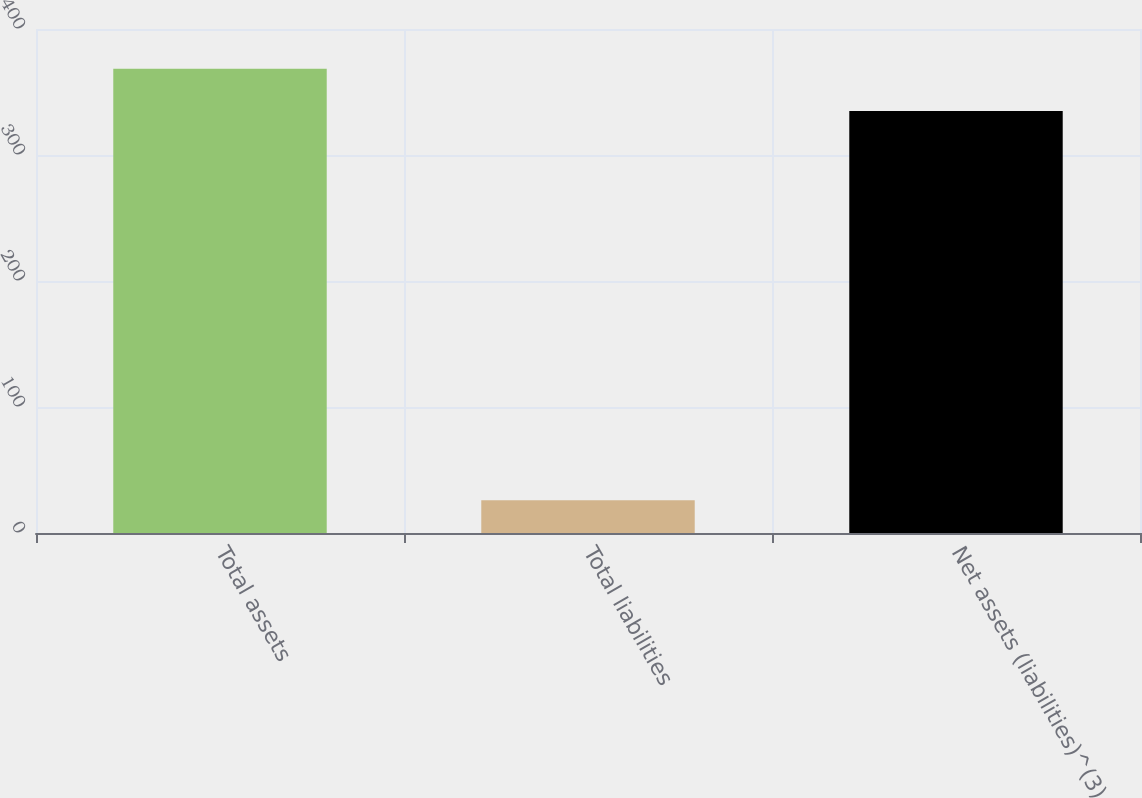Convert chart to OTSL. <chart><loc_0><loc_0><loc_500><loc_500><bar_chart><fcel>Total assets<fcel>Total liabilities<fcel>Net assets (liabilities)^(3)<nl><fcel>368.5<fcel>26<fcel>335<nl></chart> 